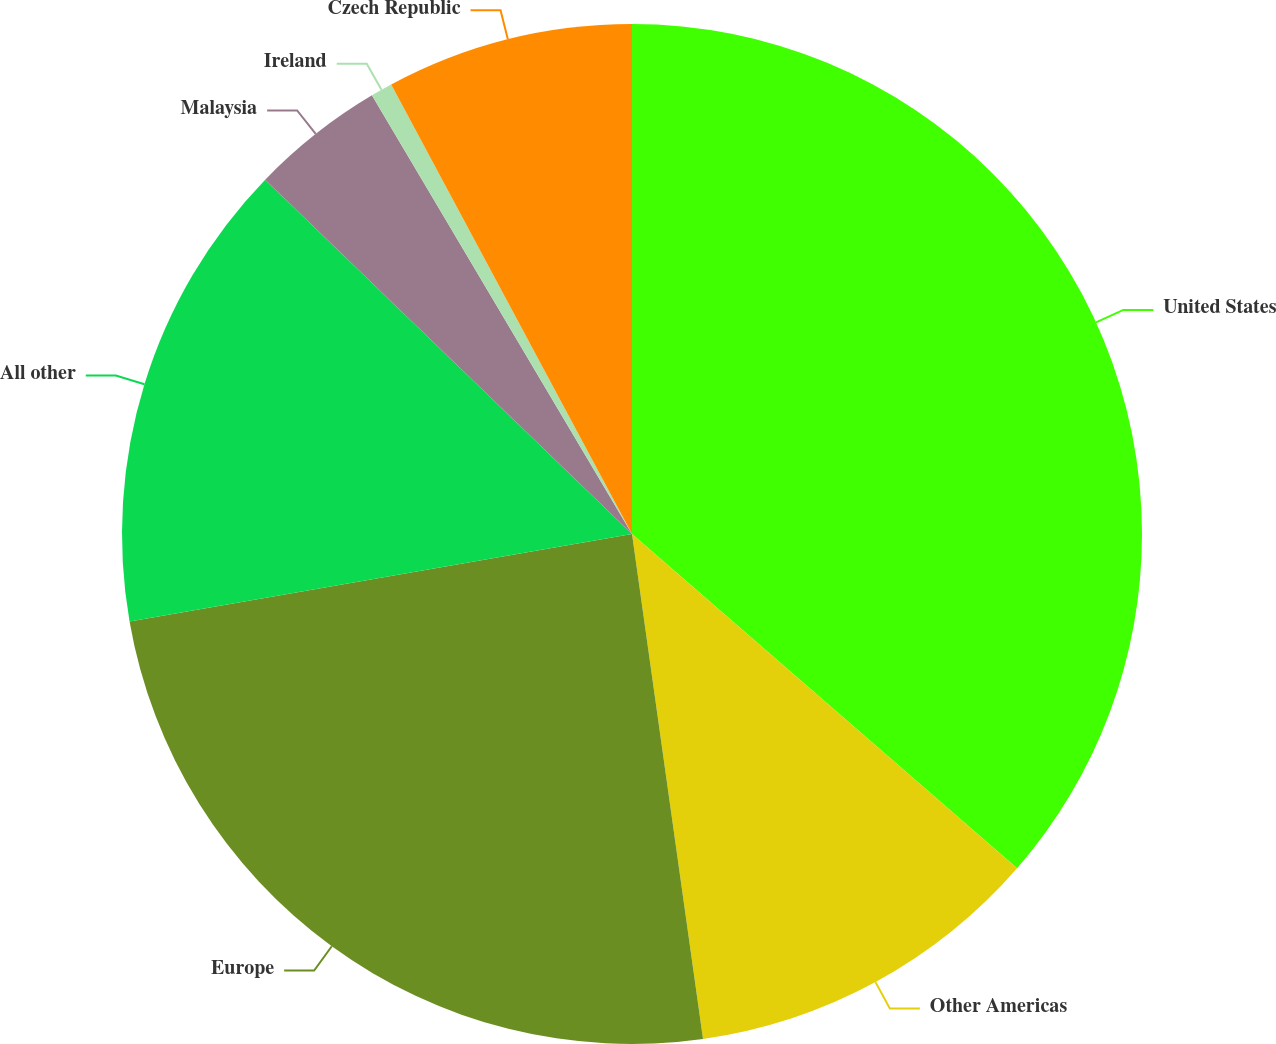Convert chart to OTSL. <chart><loc_0><loc_0><loc_500><loc_500><pie_chart><fcel>United States<fcel>Other Americas<fcel>Europe<fcel>All other<fcel>Malaysia<fcel>Ireland<fcel>Czech Republic<nl><fcel>36.39%<fcel>11.4%<fcel>24.49%<fcel>14.97%<fcel>4.26%<fcel>0.69%<fcel>7.83%<nl></chart> 